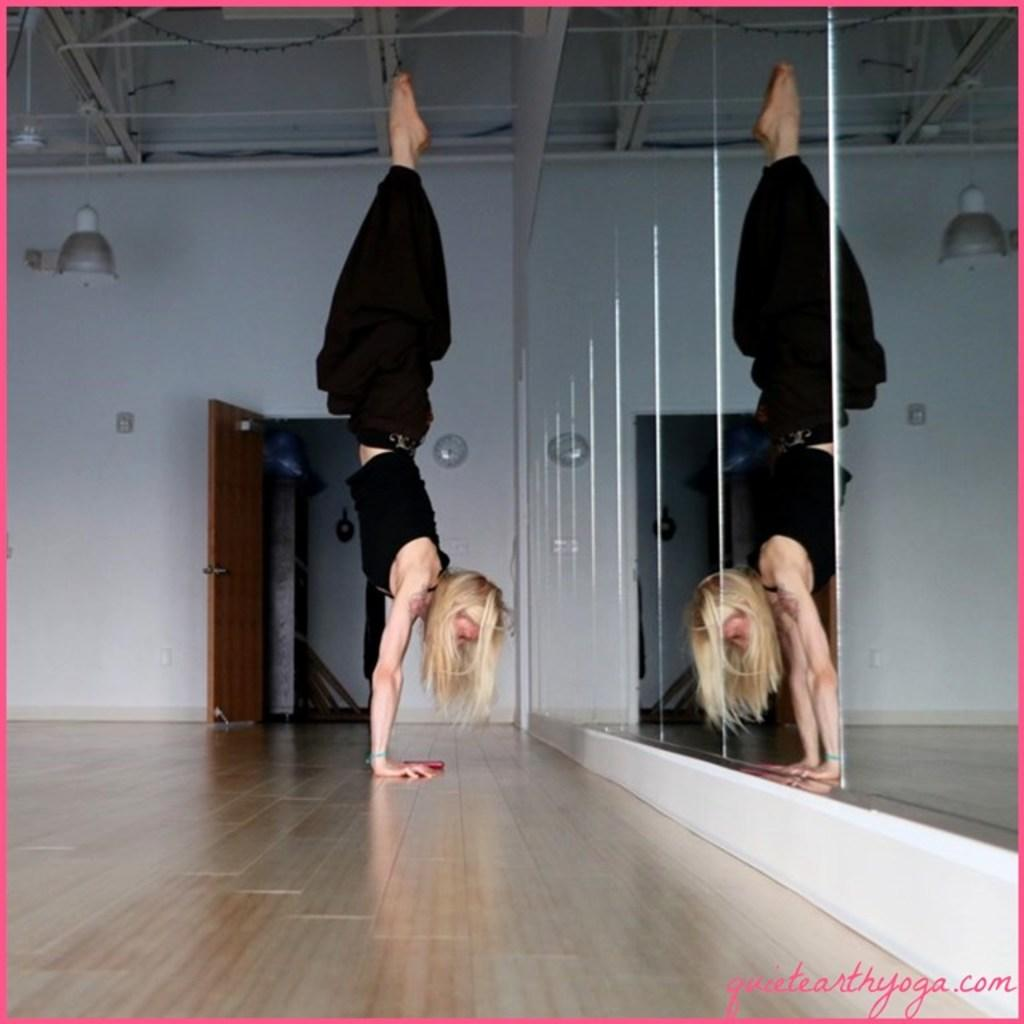What is the main subject of the image? There is a woman in the image. What is the woman doing in the image? The woman is doing gymnastics. What can be seen in the background of the image? There is a door, walls, and electric lights in the background of the image. Can you tell me how many tigers are present in the image? There are no tigers present in the image; it features a woman doing gymnastics. What type of handshake is the woman performing with her father in the image? There is no handshake or father present in the image; it shows a woman doing gymnastics. 